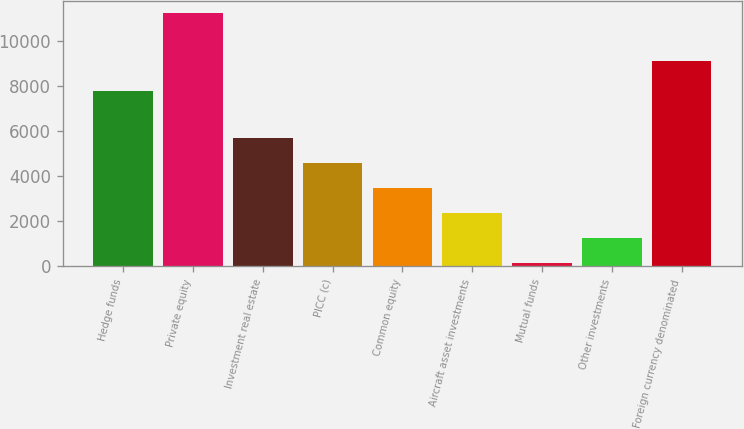<chart> <loc_0><loc_0><loc_500><loc_500><bar_chart><fcel>Hedge funds<fcel>Private equity<fcel>Investment real estate<fcel>PICC (c)<fcel>Common equity<fcel>Aircraft asset investments<fcel>Mutual funds<fcel>Other investments<fcel>Foreign currency denominated<nl><fcel>7767<fcel>11223<fcel>5675.5<fcel>4566<fcel>3456.5<fcel>2347<fcel>128<fcel>1237.5<fcel>9106<nl></chart> 